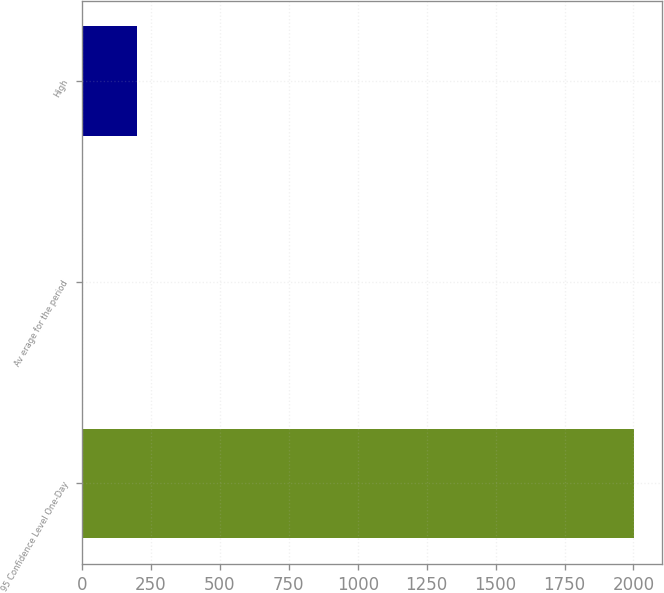Convert chart. <chart><loc_0><loc_0><loc_500><loc_500><bar_chart><fcel>95 Confidence Level One-Day<fcel>Av erage for the period<fcel>High<nl><fcel>2003<fcel>1<fcel>201.2<nl></chart> 